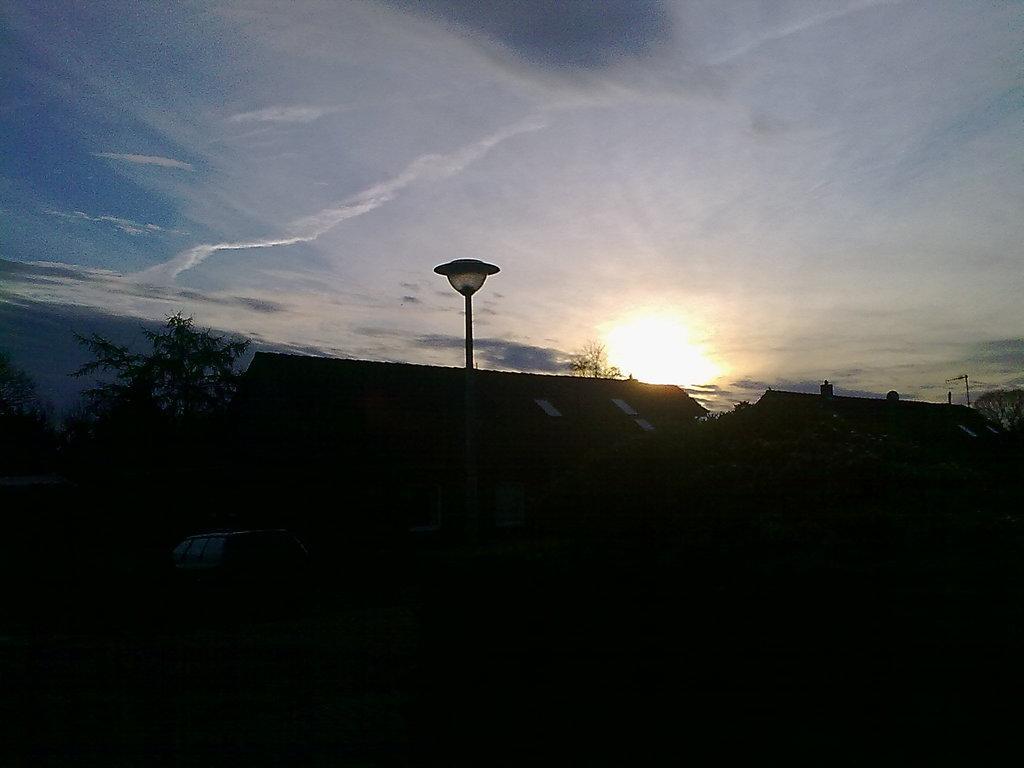Could you give a brief overview of what you see in this image? In this image we can see some houses, vehicle which is moving on the road, there are some trees and in the background of the image there is clear sky and sun. 